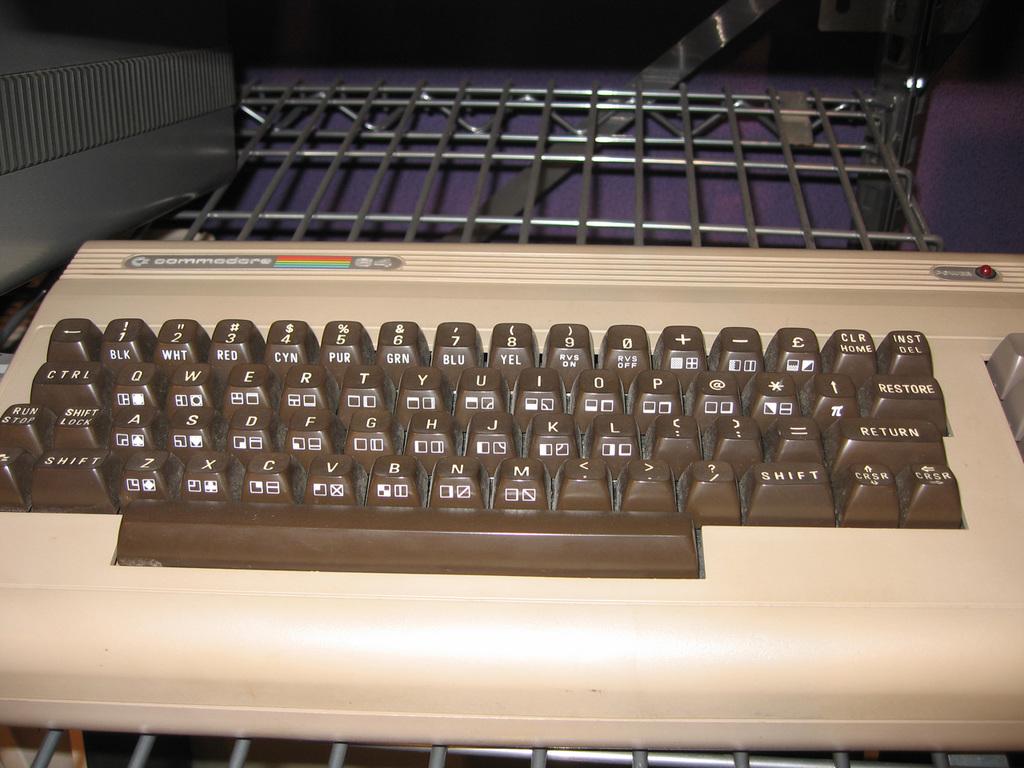What´s the letter next to the m?
Your response must be concise. N. 